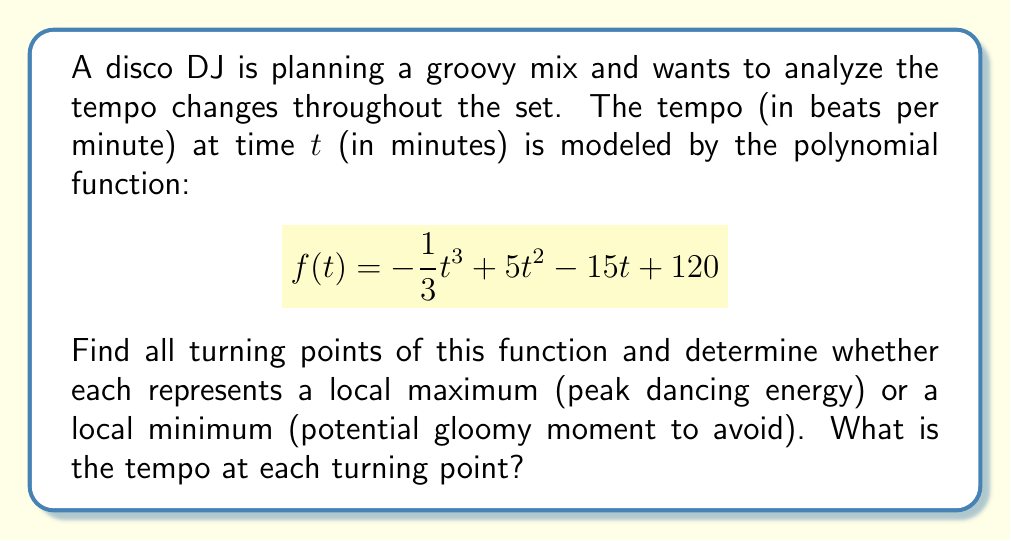Give your solution to this math problem. To find the turning points, we need to follow these steps:

1) Find the derivative of the function:
   $$f'(t) = -t^2 + 10t - 15$$

2) Set the derivative equal to zero and solve for t:
   $$-t^2 + 10t - 15 = 0$$
   
   This is a quadratic equation. We can solve it using the quadratic formula:
   $$t = \frac{-b \pm \sqrt{b^2 - 4ac}}{2a}$$
   
   Where $a=-1$, $b=10$, and $c=-15$
   
   $$t = \frac{-10 \pm \sqrt{100 - 4(-1)(-15)}}{2(-1)}$$
   $$t = \frac{-10 \pm \sqrt{40}}{-2}$$
   $$t = 5 \pm \frac{\sqrt{40}}{2}$$

3) Simplify:
   $$t_1 = 5 + \frac{\sqrt{40}}{2} \approx 8.16$$
   $$t_2 = 5 - \frac{\sqrt{40}}{2} \approx 1.84$$

4) To determine if each point is a maximum or minimum, we can use the second derivative test:
   $$f''(t) = -2t + 10$$
   
   At $t_1 \approx 8.16$: $f''(8.16) < 0$, so this is a local maximum
   At $t_2 \approx 1.84$: $f''(1.84) > 0$, so this is a local minimum

5) Calculate the tempo at each turning point:
   At $t_1 \approx 8.16$: $f(8.16) \approx 140.44$ bpm
   At $t_2 \approx 1.84$: $f(1.84) \approx 112.95$ bpm
Answer: The function has two turning points:
1) A local maximum at $t \approx 8.16$ minutes with a tempo of approximately 140.44 bpm (peak dancing energy).
2) A local minimum at $t \approx 1.84$ minutes with a tempo of approximately 112.95 bpm (potential gloomy moment to avoid). 